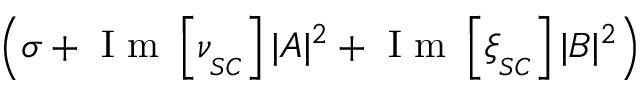Convert formula to latex. <formula><loc_0><loc_0><loc_500><loc_500>\left ( \sigma + I m \left [ \nu _ { _ { S C } } \right ] | A | ^ { 2 } + I m \left [ \xi _ { _ { S C } } \right ] | B | ^ { 2 } \right )</formula> 